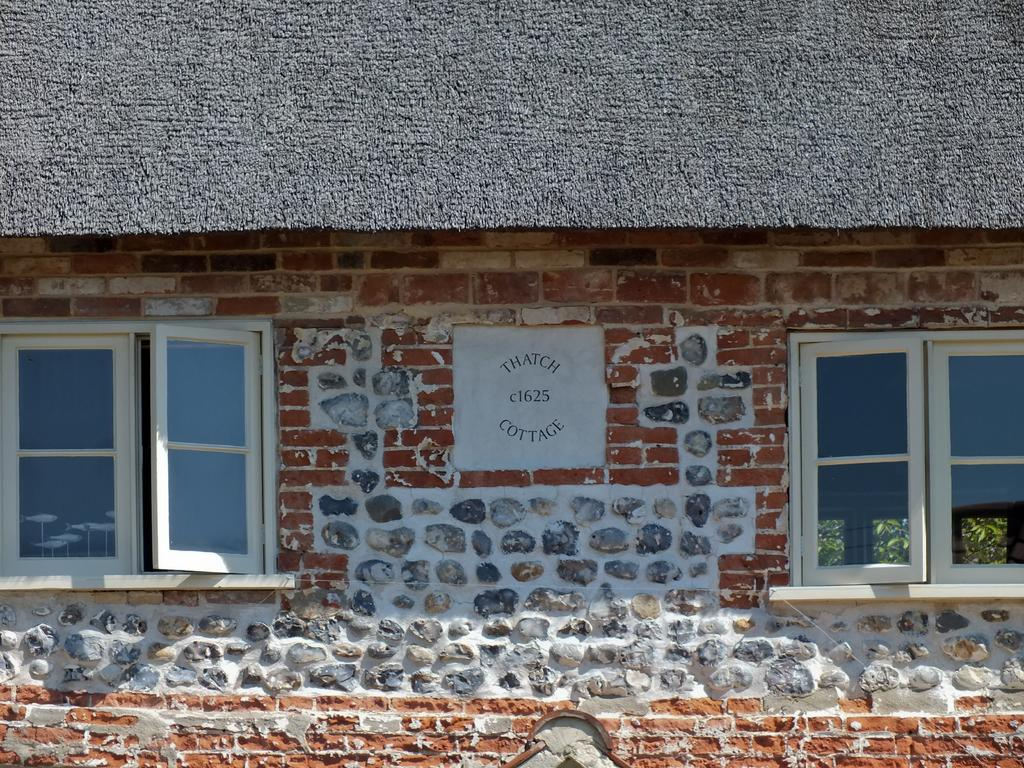What is the main structure in the picture? There is a house in the picture. What are some features of the house? The house has windows and a roof. Is there any text or writing on the house? Yes, there is something written on the wall of the house. Can you tell me how many cherries are hanging from the roof of the house in the image? There are no cherries present in the image; the house has a roof, but no cherries are hanging from it. What type of beast can be seen living in the house in the image? There is no beast present in the image; the house is a structure and does not contain any living creatures. 